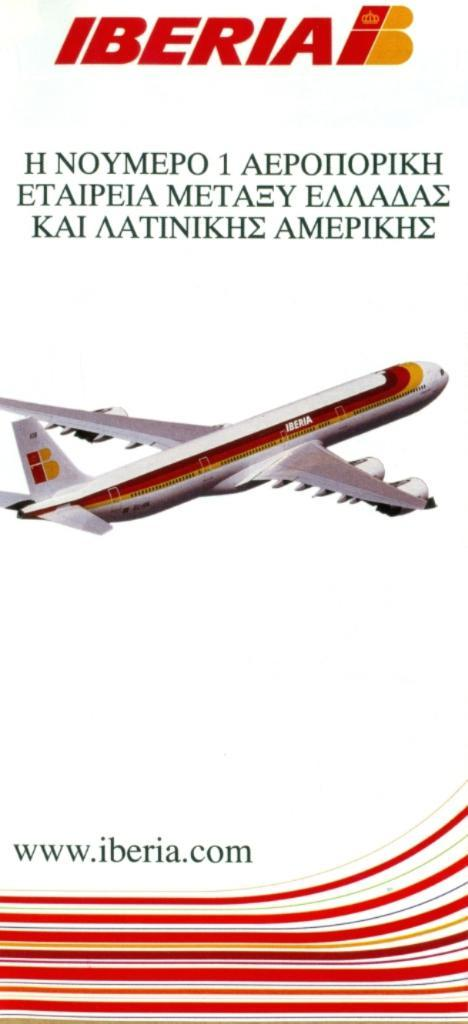<image>
Share a concise interpretation of the image provided. an Iberia pamphlet is white with a plane on it 